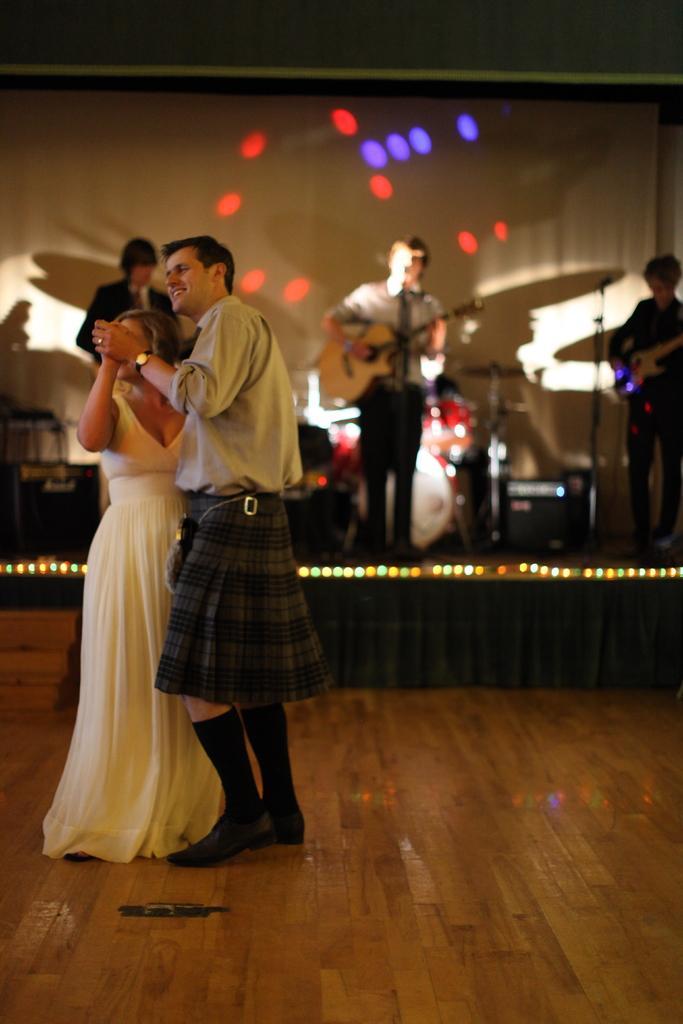Could you give a brief overview of what you see in this image? This picture is taken inside the room. In this image, on the left side, we can see two people man and woman. In the background, we can see a stage, on the right side of a stage, we can see a man standing and a playing a guitar in front of a microphone. In the middle of the stage, we can also see a person standing and playing a guitar in front of a microphone. On the left side of the stage, we can also see a person. In the background, we can see a screen with few lights. In the background, we can also see some musical instrument. At the bottom, we can see a black color curtain and a floor. 